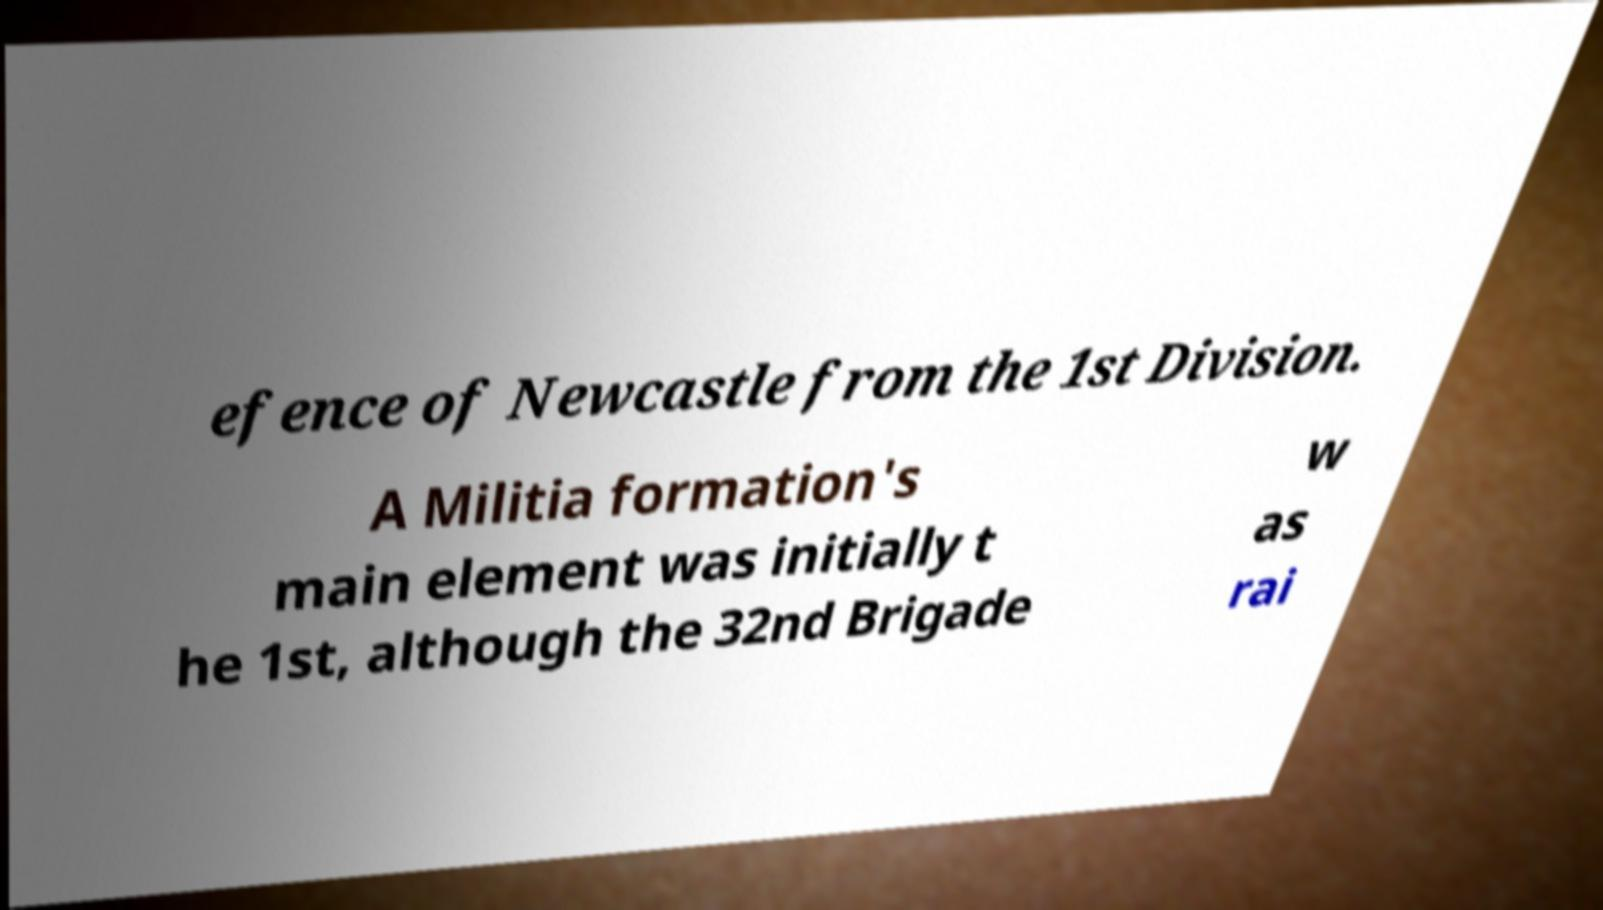Could you assist in decoding the text presented in this image and type it out clearly? efence of Newcastle from the 1st Division. A Militia formation's main element was initially t he 1st, although the 32nd Brigade w as rai 